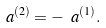Convert formula to latex. <formula><loc_0><loc_0><loc_500><loc_500>\ a ^ { ( 2 ) } = - \ a ^ { ( 1 ) } .</formula> 